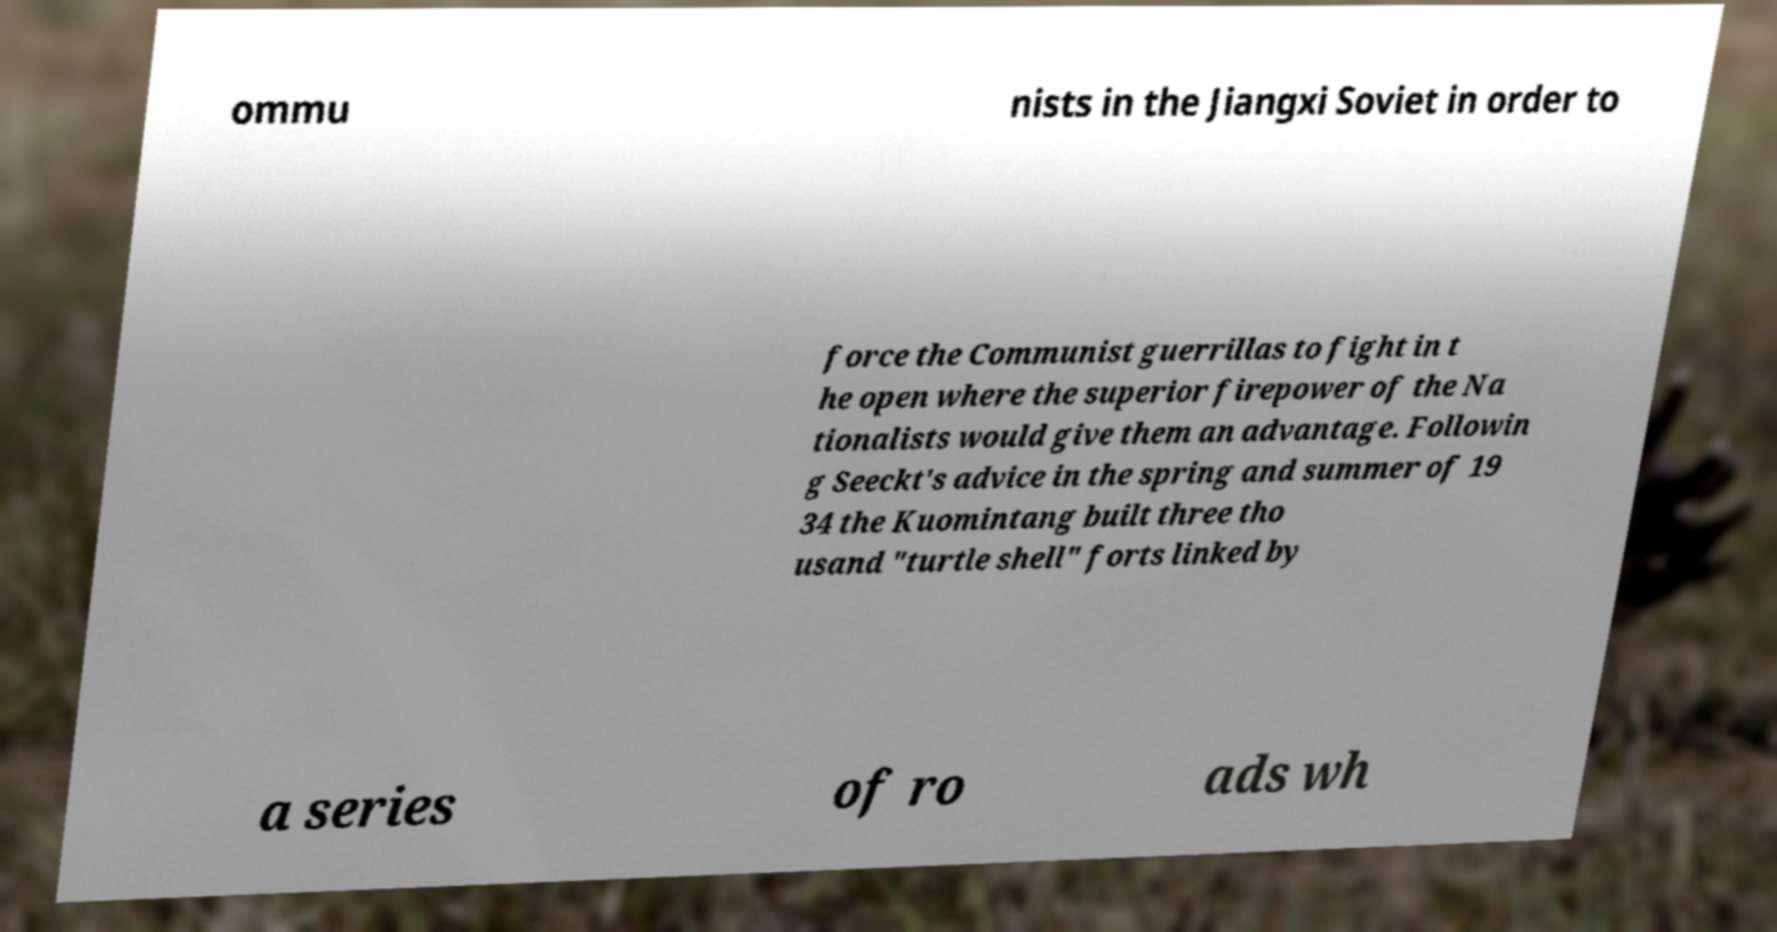Can you read and provide the text displayed in the image?This photo seems to have some interesting text. Can you extract and type it out for me? ommu nists in the Jiangxi Soviet in order to force the Communist guerrillas to fight in t he open where the superior firepower of the Na tionalists would give them an advantage. Followin g Seeckt's advice in the spring and summer of 19 34 the Kuomintang built three tho usand "turtle shell" forts linked by a series of ro ads wh 